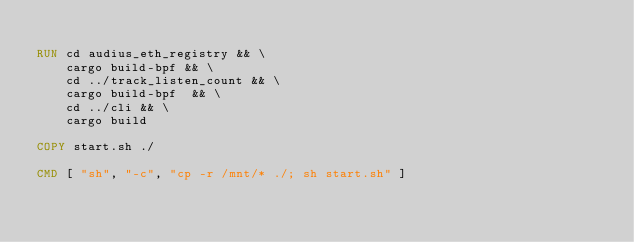<code> <loc_0><loc_0><loc_500><loc_500><_Dockerfile_>
RUN cd audius_eth_registry && \
    cargo build-bpf && \
    cd ../track_listen_count && \
    cargo build-bpf  && \
    cd ../cli && \
    cargo build

COPY start.sh ./

CMD [ "sh", "-c", "cp -r /mnt/* ./; sh start.sh" ]
</code> 